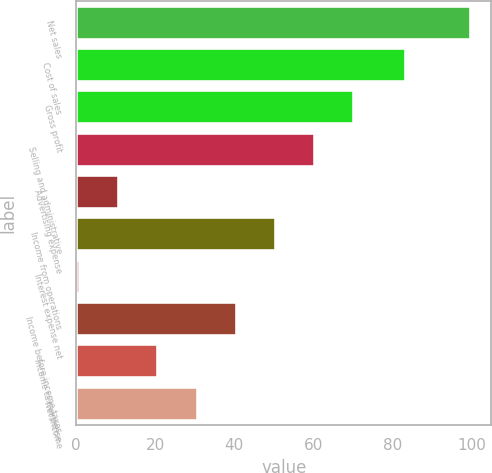Convert chart. <chart><loc_0><loc_0><loc_500><loc_500><bar_chart><fcel>Net sales<fcel>Cost of sales<fcel>Gross profit<fcel>Selling and administrative<fcel>Advertising expense<fcel>Income from operations<fcel>Interest expense net<fcel>Income before income taxes<fcel>Income tax expense<fcel>Net income<nl><fcel>100<fcel>83.4<fcel>70.3<fcel>60.4<fcel>10.9<fcel>50.5<fcel>1<fcel>40.6<fcel>20.8<fcel>30.7<nl></chart> 